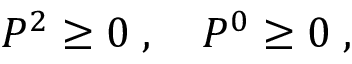<formula> <loc_0><loc_0><loc_500><loc_500>P ^ { 2 } \geq 0 \, , \quad P ^ { 0 } \geq 0 \, ,</formula> 